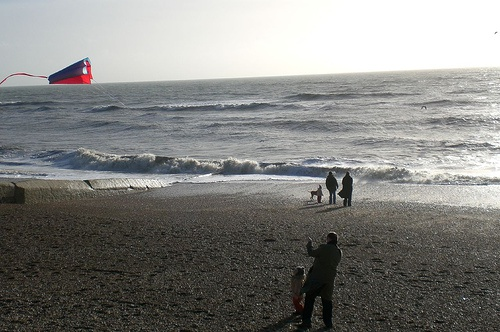Describe the objects in this image and their specific colors. I can see people in darkgray, black, and gray tones, kite in darkgray, navy, brown, black, and lightgray tones, people in darkgray, black, and gray tones, people in darkgray, black, gray, and lightgray tones, and people in darkgray, black, and gray tones in this image. 